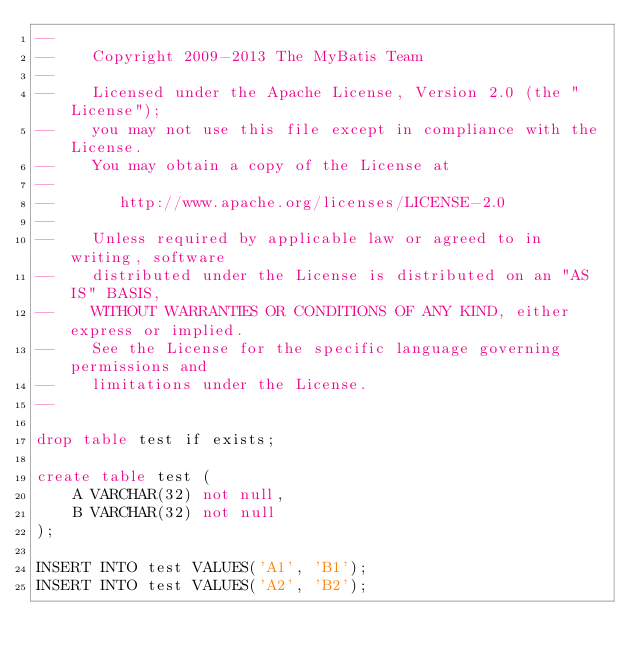<code> <loc_0><loc_0><loc_500><loc_500><_SQL_>--
--    Copyright 2009-2013 The MyBatis Team
--
--    Licensed under the Apache License, Version 2.0 (the "License");
--    you may not use this file except in compliance with the License.
--    You may obtain a copy of the License at
--
--       http://www.apache.org/licenses/LICENSE-2.0
--
--    Unless required by applicable law or agreed to in writing, software
--    distributed under the License is distributed on an "AS IS" BASIS,
--    WITHOUT WARRANTIES OR CONDITIONS OF ANY KIND, either express or implied.
--    See the License for the specific language governing permissions and
--    limitations under the License.
--

drop table test if exists;

create table test (
	A VARCHAR(32) not null,
	B VARCHAR(32) not null
);

INSERT INTO test VALUES('A1', 'B1');
INSERT INTO test VALUES('A2', 'B2');</code> 